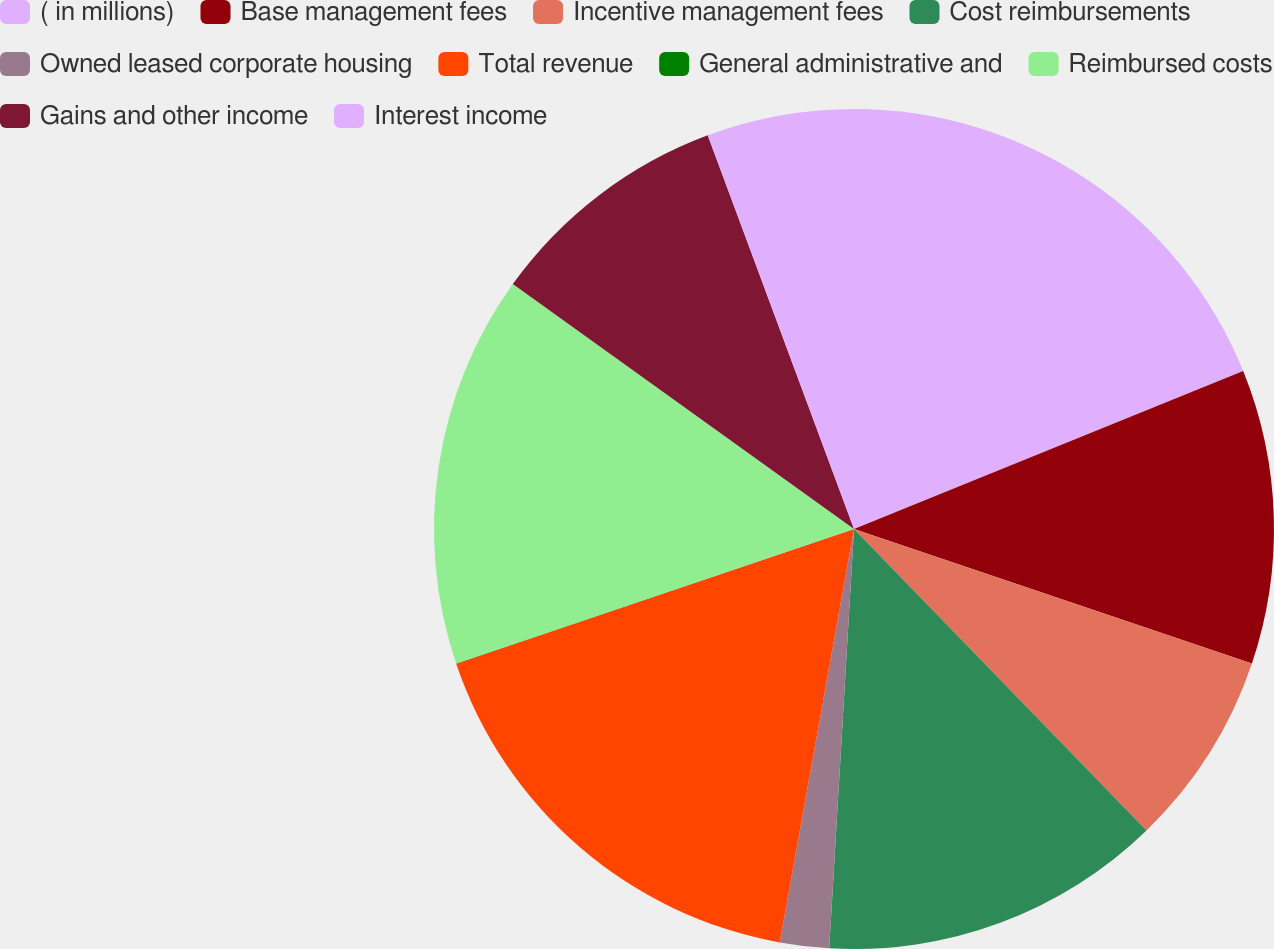Convert chart. <chart><loc_0><loc_0><loc_500><loc_500><pie_chart><fcel>( in millions)<fcel>Base management fees<fcel>Incentive management fees<fcel>Cost reimbursements<fcel>Owned leased corporate housing<fcel>Total revenue<fcel>General administrative and<fcel>Reimbursed costs<fcel>Gains and other income<fcel>Interest income<nl><fcel>18.86%<fcel>11.32%<fcel>7.55%<fcel>13.2%<fcel>1.89%<fcel>16.97%<fcel>0.01%<fcel>15.09%<fcel>9.43%<fcel>5.66%<nl></chart> 